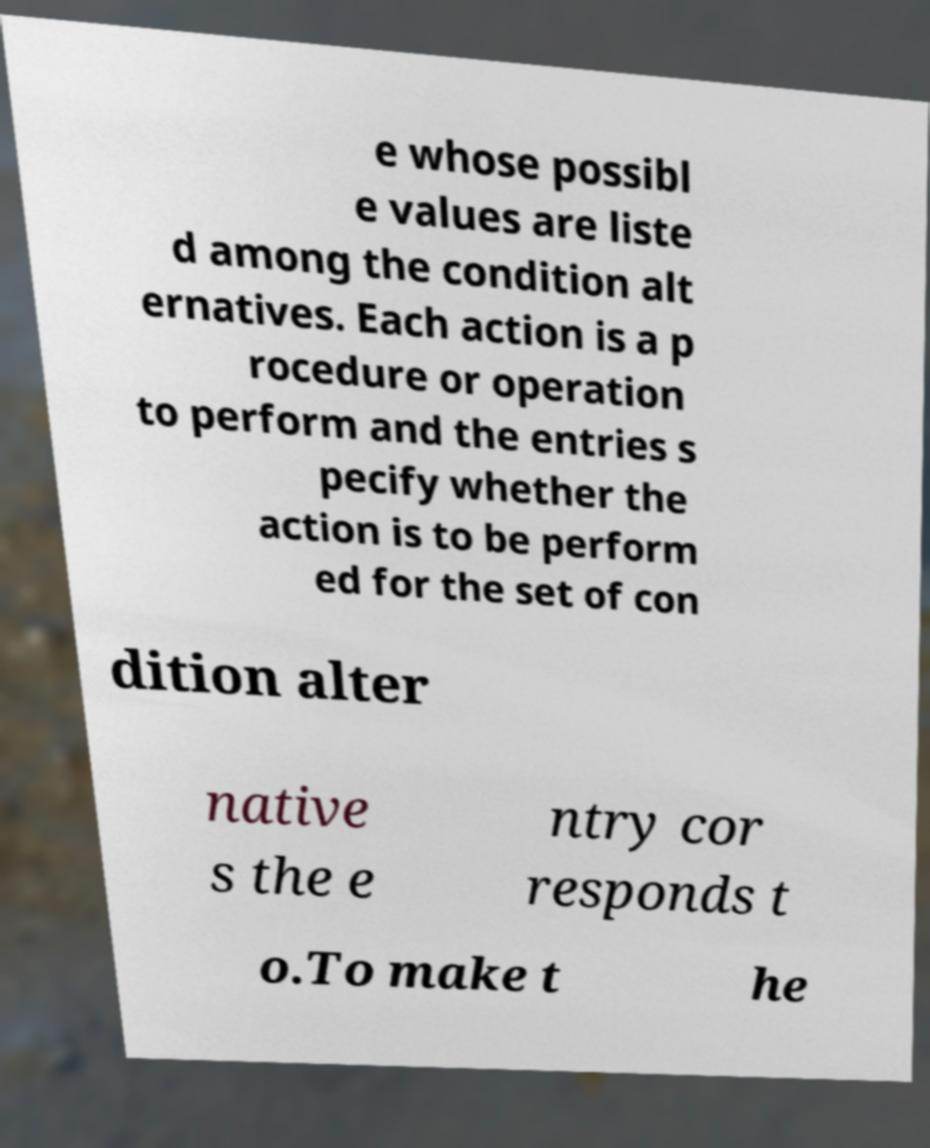What messages or text are displayed in this image? I need them in a readable, typed format. e whose possibl e values are liste d among the condition alt ernatives. Each action is a p rocedure or operation to perform and the entries s pecify whether the action is to be perform ed for the set of con dition alter native s the e ntry cor responds t o.To make t he 